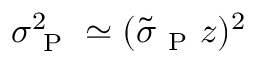<formula> <loc_0><loc_0><loc_500><loc_500>\sigma _ { P } ^ { 2 } \simeq ( \tilde { \sigma } _ { P } z ) ^ { 2 }</formula> 